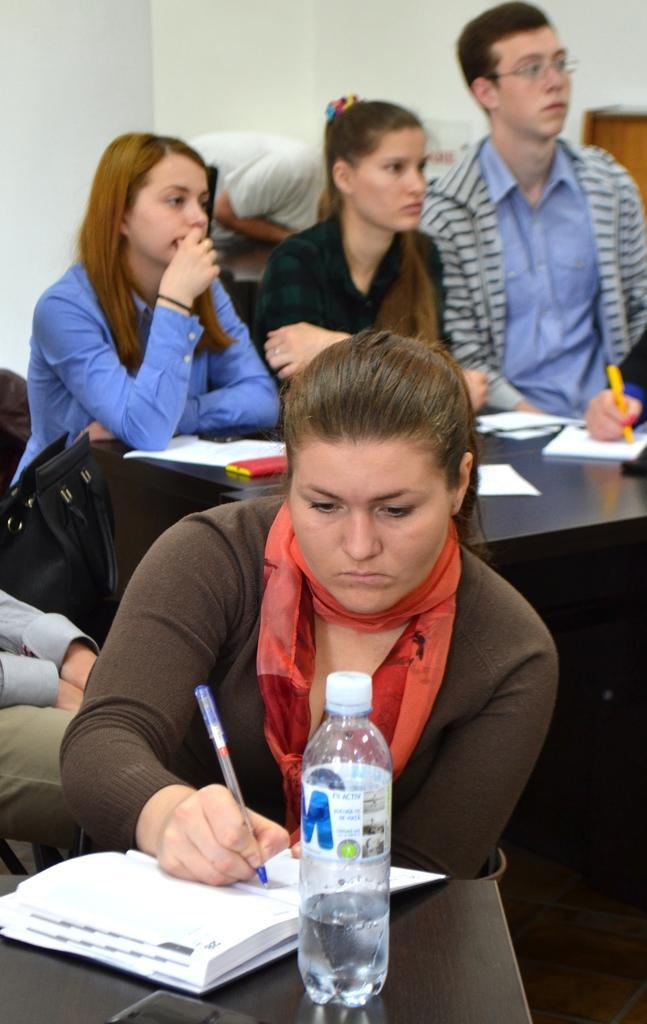Please provide a concise description of this image. In this image there are group of persons sitting at the foreground of the image there is a woman who is writing in the book and there is a water bottle in front of her and at the back side of the image there is a person who is bending down and at the left side of the image there is a lady person holding a handbag 